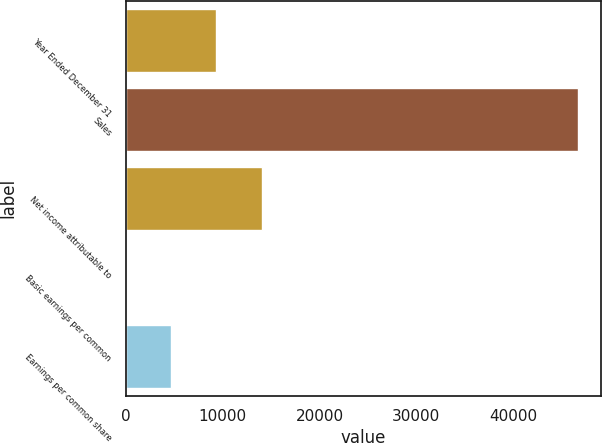Convert chart. <chart><loc_0><loc_0><loc_500><loc_500><bar_chart><fcel>Year Ended December 31<fcel>Sales<fcel>Net income attributable to<fcel>Basic earnings per common<fcel>Earnings per common share<nl><fcel>9348.14<fcel>46737<fcel>14021.8<fcel>0.92<fcel>4674.53<nl></chart> 